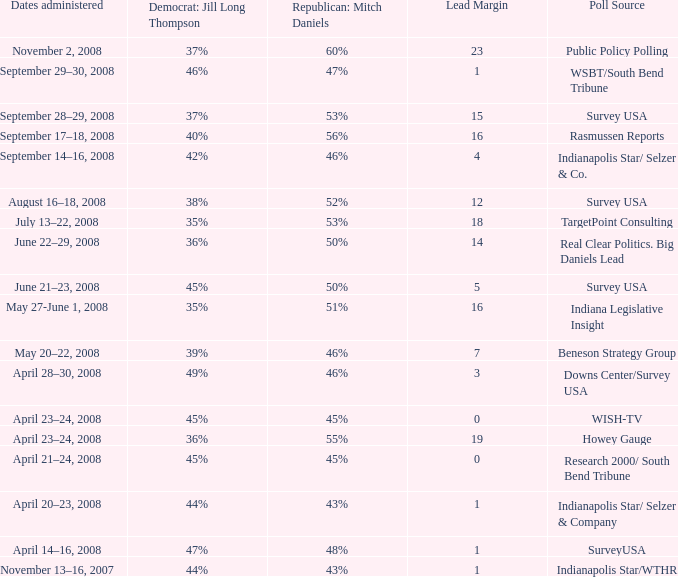What is the lowest Lead Margin when Republican: Mitch Daniels was polling at 48%? 1.0. 